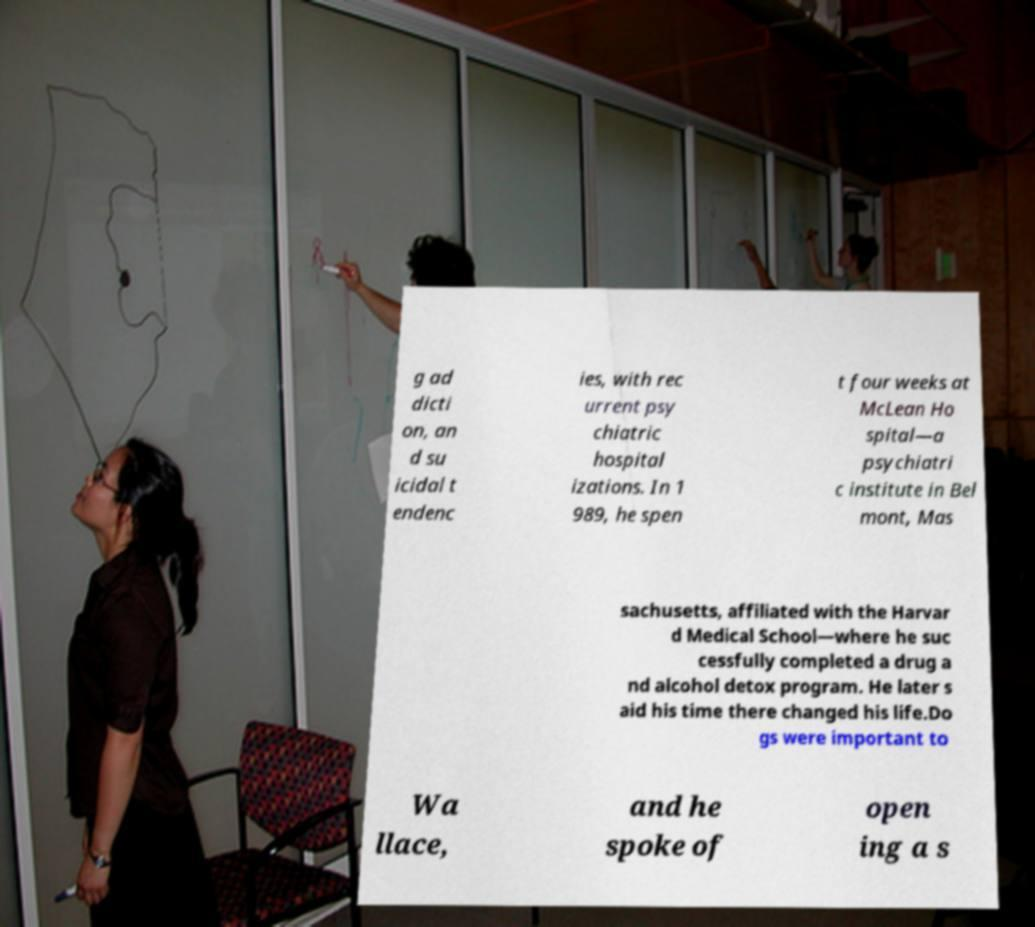Could you assist in decoding the text presented in this image and type it out clearly? g ad dicti on, an d su icidal t endenc ies, with rec urrent psy chiatric hospital izations. In 1 989, he spen t four weeks at McLean Ho spital—a psychiatri c institute in Bel mont, Mas sachusetts, affiliated with the Harvar d Medical School—where he suc cessfully completed a drug a nd alcohol detox program. He later s aid his time there changed his life.Do gs were important to Wa llace, and he spoke of open ing a s 